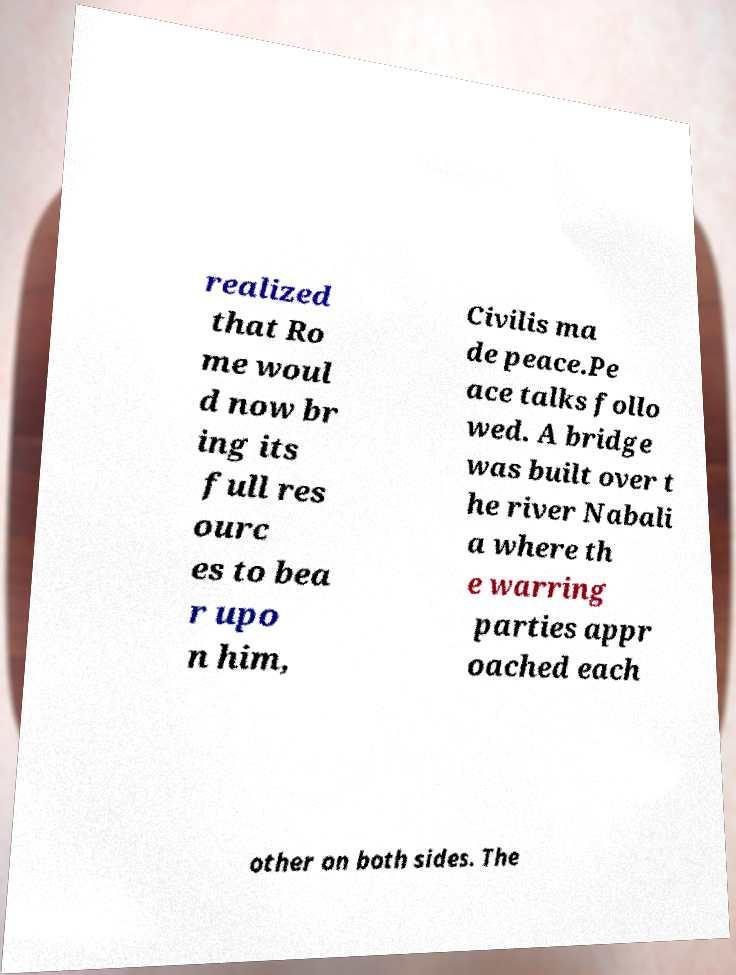Could you assist in decoding the text presented in this image and type it out clearly? realized that Ro me woul d now br ing its full res ourc es to bea r upo n him, Civilis ma de peace.Pe ace talks follo wed. A bridge was built over t he river Nabali a where th e warring parties appr oached each other on both sides. The 